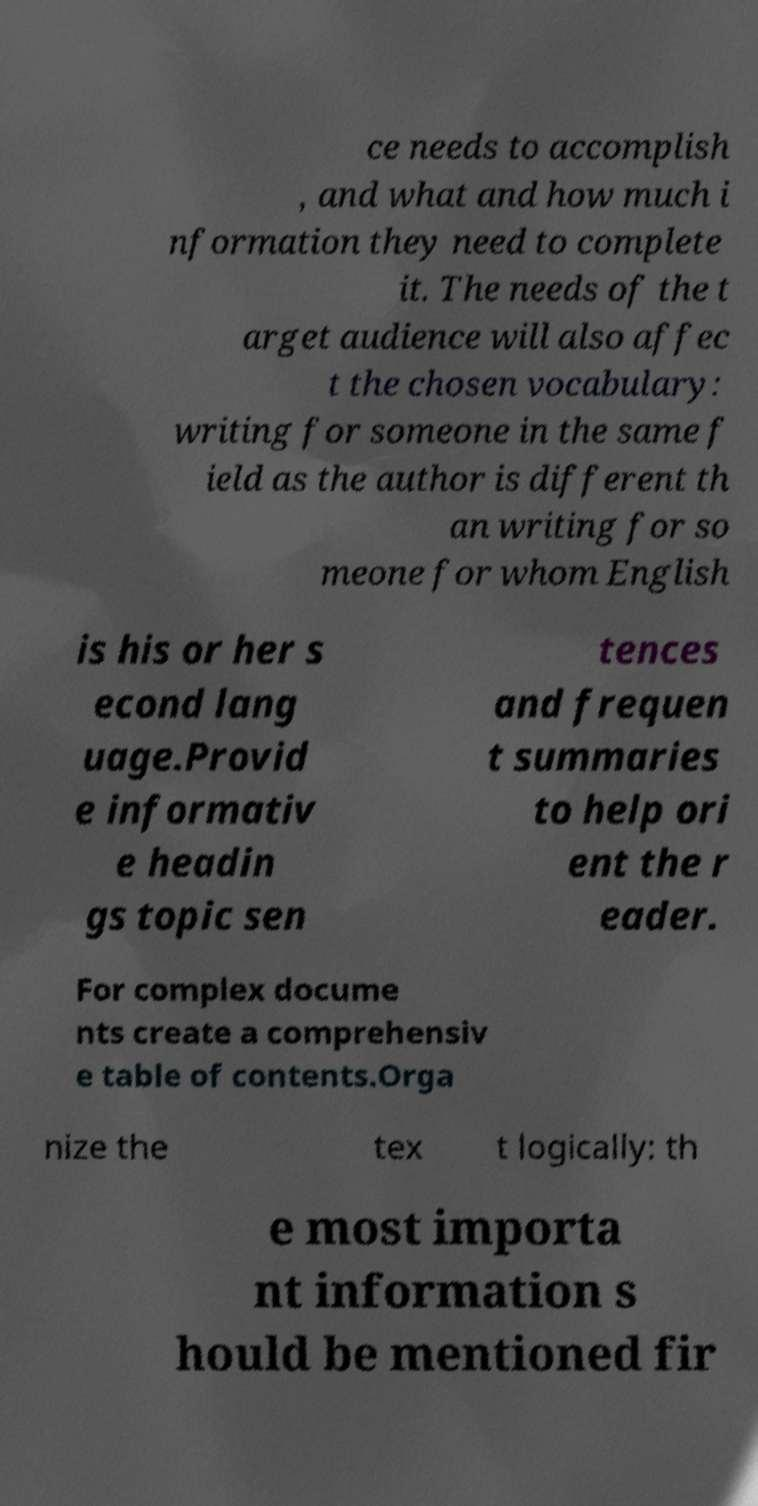Can you read and provide the text displayed in the image?This photo seems to have some interesting text. Can you extract and type it out for me? ce needs to accomplish , and what and how much i nformation they need to complete it. The needs of the t arget audience will also affec t the chosen vocabulary: writing for someone in the same f ield as the author is different th an writing for so meone for whom English is his or her s econd lang uage.Provid e informativ e headin gs topic sen tences and frequen t summaries to help ori ent the r eader. For complex docume nts create a comprehensiv e table of contents.Orga nize the tex t logically: th e most importa nt information s hould be mentioned fir 